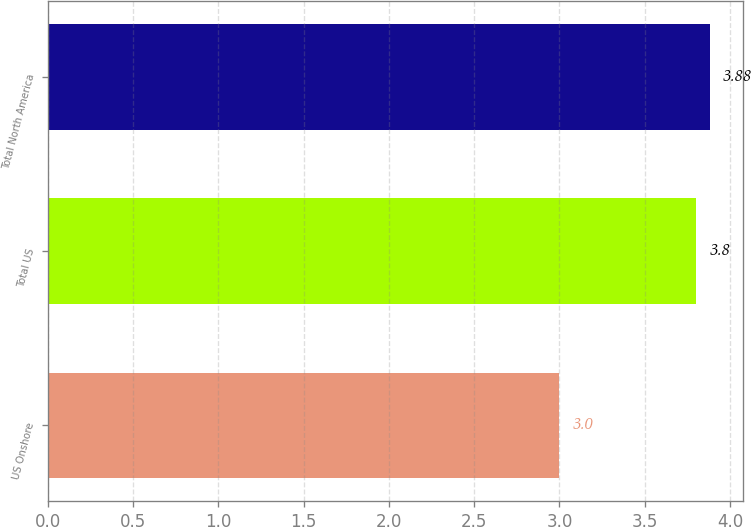Convert chart. <chart><loc_0><loc_0><loc_500><loc_500><bar_chart><fcel>US Onshore<fcel>Total US<fcel>Total North America<nl><fcel>3<fcel>3.8<fcel>3.88<nl></chart> 